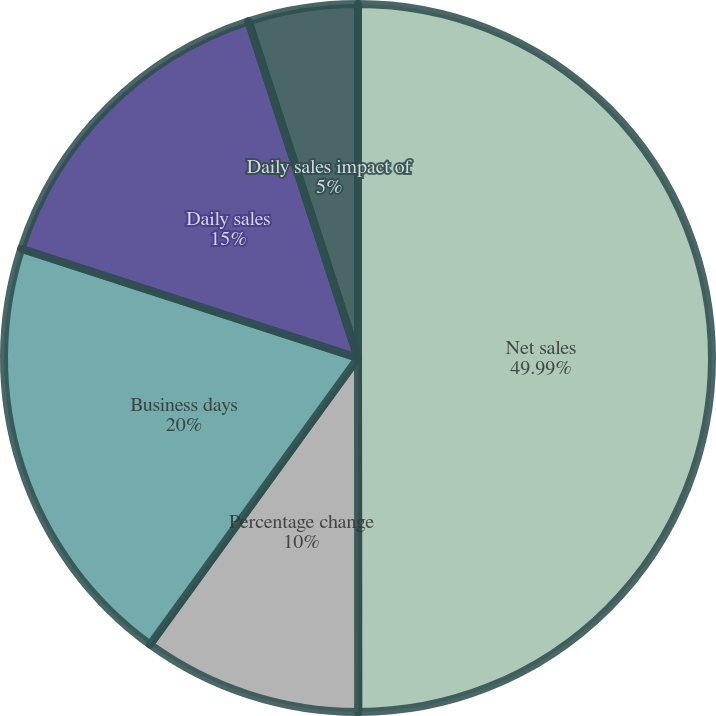Convert chart. <chart><loc_0><loc_0><loc_500><loc_500><pie_chart><fcel>Net sales<fcel>Percentage change<fcel>Business days<fcel>Daily sales<fcel>Daily sales impact of currency<fcel>Daily sales impact of<nl><fcel>49.99%<fcel>10.0%<fcel>20.0%<fcel>15.0%<fcel>0.01%<fcel>5.0%<nl></chart> 